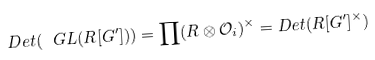Convert formula to latex. <formula><loc_0><loc_0><loc_500><loc_500>D e t ( \ G L ( R [ G ^ { \prime } ] ) ) = \prod ( R \otimes \mathcal { O } _ { i } ) ^ { \times } = D e t ( R [ G ^ { \prime } ] ^ { \times } )</formula> 